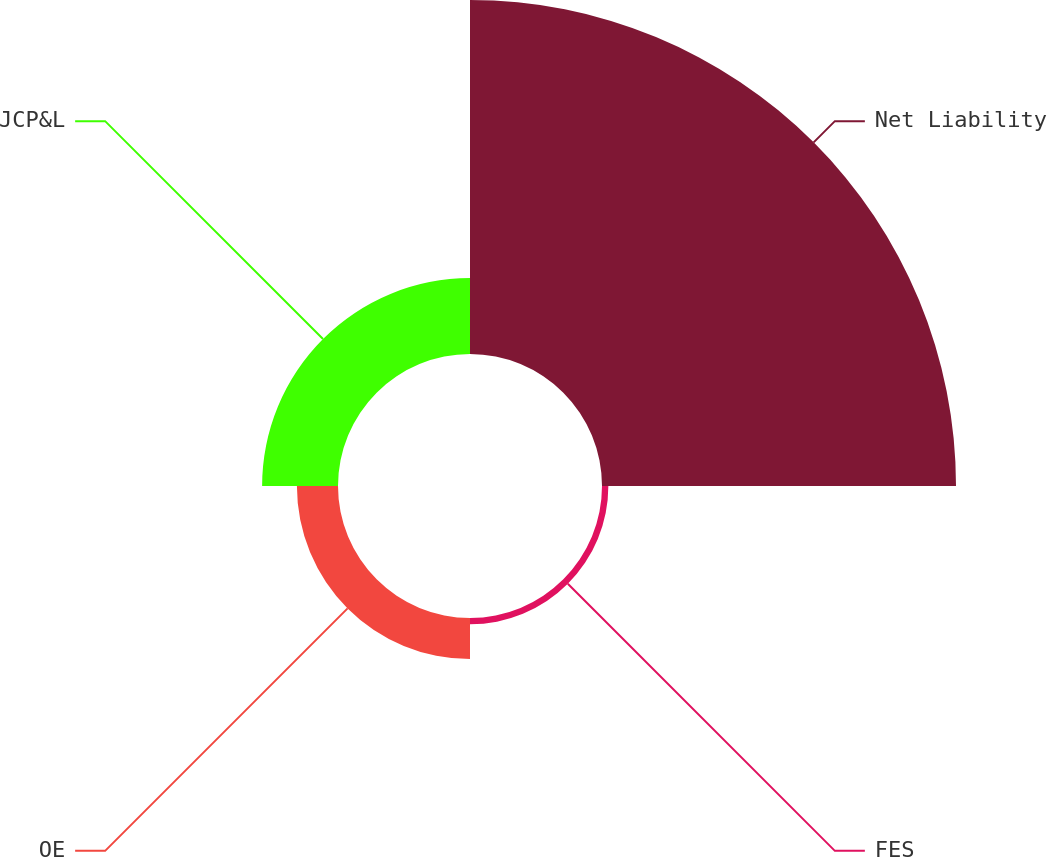Convert chart. <chart><loc_0><loc_0><loc_500><loc_500><pie_chart><fcel>Net Liability<fcel>FES<fcel>OE<fcel>JCP&L<nl><fcel>74.17%<fcel>1.33%<fcel>8.61%<fcel>15.9%<nl></chart> 